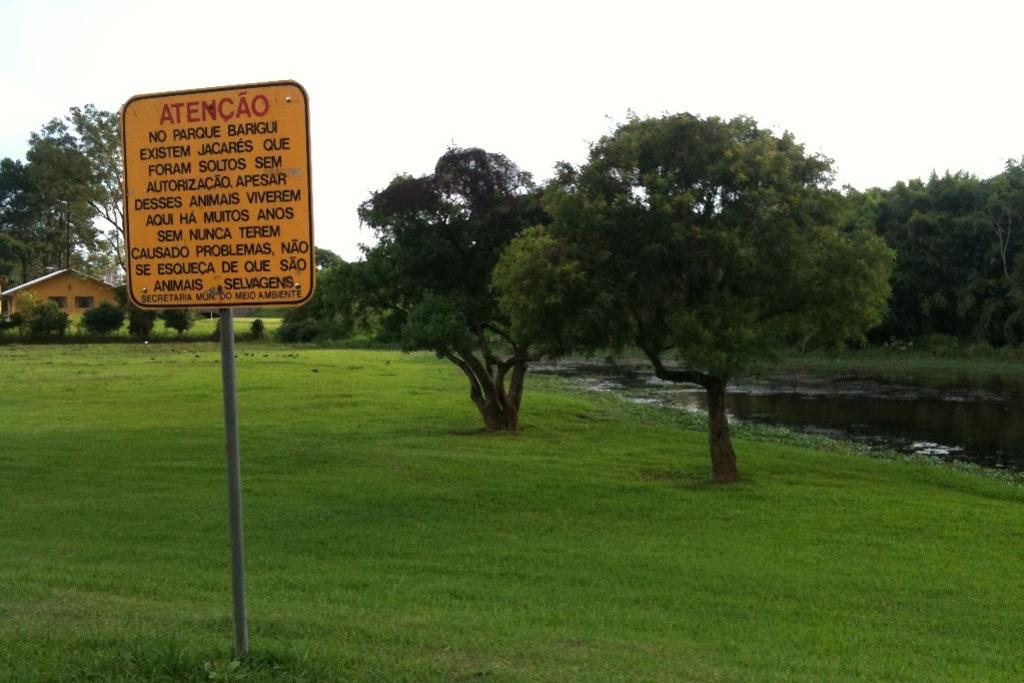What is located on the left side of the image? There is a sign board on the left side of the image. What can be found on the sign board? There is text on the sign board. What can be seen in the background of the image? The sky, trees, a house, grass, and water are visible in the background of the image. Is the room in the image hot or cold? There is no room present in the image, so it is not possible to determine if it is hot or cold. 